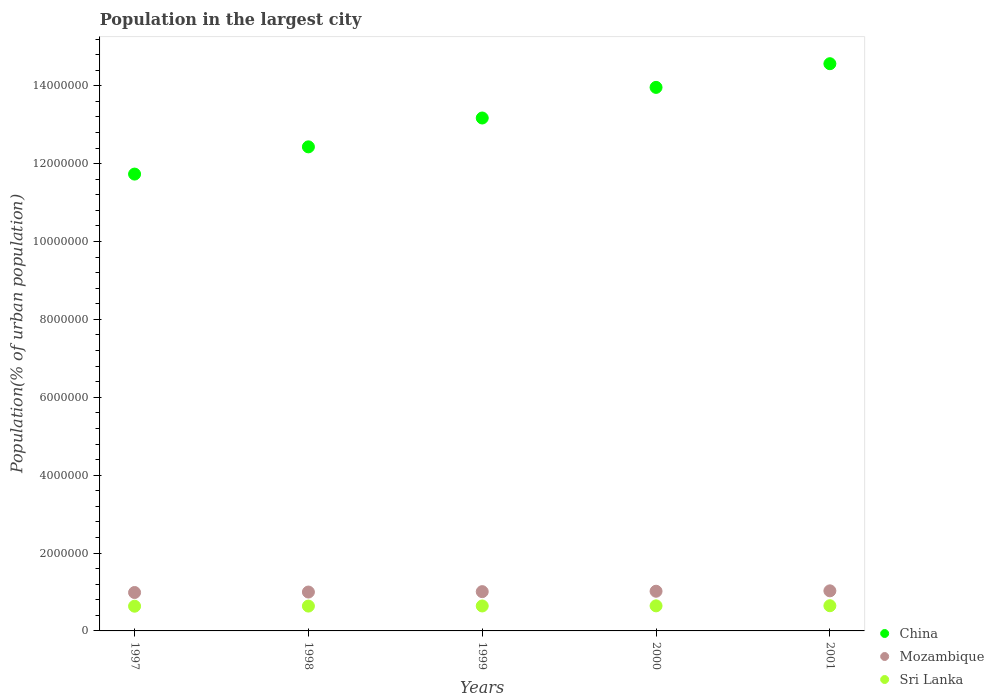Is the number of dotlines equal to the number of legend labels?
Ensure brevity in your answer.  Yes. What is the population in the largest city in Sri Lanka in 1999?
Your response must be concise. 6.41e+05. Across all years, what is the maximum population in the largest city in Sri Lanka?
Keep it short and to the point. 6.47e+05. Across all years, what is the minimum population in the largest city in Sri Lanka?
Make the answer very short. 6.35e+05. In which year was the population in the largest city in China minimum?
Offer a terse response. 1997. What is the total population in the largest city in Sri Lanka in the graph?
Your answer should be compact. 3.20e+06. What is the difference between the population in the largest city in Sri Lanka in 1999 and that in 2000?
Provide a short and direct response. -3049. What is the difference between the population in the largest city in Mozambique in 1999 and the population in the largest city in China in 2000?
Provide a succinct answer. -1.30e+07. What is the average population in the largest city in China per year?
Give a very brief answer. 1.32e+07. In the year 2001, what is the difference between the population in the largest city in Sri Lanka and population in the largest city in Mozambique?
Give a very brief answer. -3.82e+05. What is the ratio of the population in the largest city in Mozambique in 1999 to that in 2000?
Your answer should be compact. 0.99. Is the difference between the population in the largest city in Sri Lanka in 1997 and 1999 greater than the difference between the population in the largest city in Mozambique in 1997 and 1999?
Your response must be concise. Yes. What is the difference between the highest and the second highest population in the largest city in China?
Provide a short and direct response. 6.08e+05. What is the difference between the highest and the lowest population in the largest city in Mozambique?
Offer a terse response. 4.28e+04. Is the sum of the population in the largest city in Mozambique in 1997 and 1998 greater than the maximum population in the largest city in China across all years?
Offer a very short reply. No. How many years are there in the graph?
Your response must be concise. 5. What is the difference between two consecutive major ticks on the Y-axis?
Provide a short and direct response. 2.00e+06. Are the values on the major ticks of Y-axis written in scientific E-notation?
Your answer should be very brief. No. What is the title of the graph?
Your response must be concise. Population in the largest city. What is the label or title of the X-axis?
Make the answer very short. Years. What is the label or title of the Y-axis?
Your answer should be very brief. Population(% of urban population). What is the Population(% of urban population) of China in 1997?
Offer a very short reply. 1.17e+07. What is the Population(% of urban population) in Mozambique in 1997?
Your answer should be very brief. 9.87e+05. What is the Population(% of urban population) in Sri Lanka in 1997?
Make the answer very short. 6.35e+05. What is the Population(% of urban population) of China in 1998?
Keep it short and to the point. 1.24e+07. What is the Population(% of urban population) in Mozambique in 1998?
Offer a very short reply. 9.99e+05. What is the Population(% of urban population) in Sri Lanka in 1998?
Ensure brevity in your answer.  6.38e+05. What is the Population(% of urban population) of China in 1999?
Ensure brevity in your answer.  1.32e+07. What is the Population(% of urban population) in Mozambique in 1999?
Your response must be concise. 1.01e+06. What is the Population(% of urban population) of Sri Lanka in 1999?
Your answer should be very brief. 6.41e+05. What is the Population(% of urban population) of China in 2000?
Make the answer very short. 1.40e+07. What is the Population(% of urban population) in Mozambique in 2000?
Provide a succinct answer. 1.02e+06. What is the Population(% of urban population) in Sri Lanka in 2000?
Ensure brevity in your answer.  6.44e+05. What is the Population(% of urban population) in China in 2001?
Provide a succinct answer. 1.46e+07. What is the Population(% of urban population) in Mozambique in 2001?
Give a very brief answer. 1.03e+06. What is the Population(% of urban population) in Sri Lanka in 2001?
Your answer should be very brief. 6.47e+05. Across all years, what is the maximum Population(% of urban population) in China?
Provide a succinct answer. 1.46e+07. Across all years, what is the maximum Population(% of urban population) in Mozambique?
Your answer should be very brief. 1.03e+06. Across all years, what is the maximum Population(% of urban population) in Sri Lanka?
Your response must be concise. 6.47e+05. Across all years, what is the minimum Population(% of urban population) in China?
Ensure brevity in your answer.  1.17e+07. Across all years, what is the minimum Population(% of urban population) of Mozambique?
Your answer should be compact. 9.87e+05. Across all years, what is the minimum Population(% of urban population) in Sri Lanka?
Offer a terse response. 6.35e+05. What is the total Population(% of urban population) in China in the graph?
Your answer should be very brief. 6.59e+07. What is the total Population(% of urban population) in Mozambique in the graph?
Your answer should be very brief. 5.04e+06. What is the total Population(% of urban population) of Sri Lanka in the graph?
Give a very brief answer. 3.20e+06. What is the difference between the Population(% of urban population) in China in 1997 and that in 1998?
Provide a succinct answer. -6.99e+05. What is the difference between the Population(% of urban population) of Mozambique in 1997 and that in 1998?
Keep it short and to the point. -1.21e+04. What is the difference between the Population(% of urban population) in Sri Lanka in 1997 and that in 1998?
Keep it short and to the point. -3016. What is the difference between the Population(% of urban population) in China in 1997 and that in 1999?
Provide a succinct answer. -1.44e+06. What is the difference between the Population(% of urban population) in Mozambique in 1997 and that in 1999?
Keep it short and to the point. -2.22e+04. What is the difference between the Population(% of urban population) of Sri Lanka in 1997 and that in 1999?
Make the answer very short. -6046. What is the difference between the Population(% of urban population) of China in 1997 and that in 2000?
Your answer should be very brief. -2.23e+06. What is the difference between the Population(% of urban population) in Mozambique in 1997 and that in 2000?
Ensure brevity in your answer.  -3.25e+04. What is the difference between the Population(% of urban population) in Sri Lanka in 1997 and that in 2000?
Your answer should be very brief. -9095. What is the difference between the Population(% of urban population) in China in 1997 and that in 2001?
Your answer should be compact. -2.83e+06. What is the difference between the Population(% of urban population) of Mozambique in 1997 and that in 2001?
Provide a short and direct response. -4.28e+04. What is the difference between the Population(% of urban population) in Sri Lanka in 1997 and that in 2001?
Offer a very short reply. -1.22e+04. What is the difference between the Population(% of urban population) in China in 1998 and that in 1999?
Your answer should be compact. -7.41e+05. What is the difference between the Population(% of urban population) of Mozambique in 1998 and that in 1999?
Keep it short and to the point. -1.01e+04. What is the difference between the Population(% of urban population) in Sri Lanka in 1998 and that in 1999?
Offer a terse response. -3030. What is the difference between the Population(% of urban population) of China in 1998 and that in 2000?
Keep it short and to the point. -1.53e+06. What is the difference between the Population(% of urban population) of Mozambique in 1998 and that in 2000?
Keep it short and to the point. -2.04e+04. What is the difference between the Population(% of urban population) in Sri Lanka in 1998 and that in 2000?
Make the answer very short. -6079. What is the difference between the Population(% of urban population) of China in 1998 and that in 2001?
Your answer should be compact. -2.14e+06. What is the difference between the Population(% of urban population) of Mozambique in 1998 and that in 2001?
Your response must be concise. -3.07e+04. What is the difference between the Population(% of urban population) in Sri Lanka in 1998 and that in 2001?
Make the answer very short. -9134. What is the difference between the Population(% of urban population) in China in 1999 and that in 2000?
Your response must be concise. -7.86e+05. What is the difference between the Population(% of urban population) in Mozambique in 1999 and that in 2000?
Your answer should be compact. -1.03e+04. What is the difference between the Population(% of urban population) in Sri Lanka in 1999 and that in 2000?
Your response must be concise. -3049. What is the difference between the Population(% of urban population) in China in 1999 and that in 2001?
Keep it short and to the point. -1.39e+06. What is the difference between the Population(% of urban population) of Mozambique in 1999 and that in 2001?
Make the answer very short. -2.06e+04. What is the difference between the Population(% of urban population) in Sri Lanka in 1999 and that in 2001?
Ensure brevity in your answer.  -6104. What is the difference between the Population(% of urban population) in China in 2000 and that in 2001?
Your response must be concise. -6.08e+05. What is the difference between the Population(% of urban population) in Mozambique in 2000 and that in 2001?
Make the answer very short. -1.03e+04. What is the difference between the Population(% of urban population) of Sri Lanka in 2000 and that in 2001?
Provide a short and direct response. -3055. What is the difference between the Population(% of urban population) in China in 1997 and the Population(% of urban population) in Mozambique in 1998?
Offer a terse response. 1.07e+07. What is the difference between the Population(% of urban population) in China in 1997 and the Population(% of urban population) in Sri Lanka in 1998?
Provide a short and direct response. 1.11e+07. What is the difference between the Population(% of urban population) of Mozambique in 1997 and the Population(% of urban population) of Sri Lanka in 1998?
Provide a short and direct response. 3.49e+05. What is the difference between the Population(% of urban population) of China in 1997 and the Population(% of urban population) of Mozambique in 1999?
Offer a terse response. 1.07e+07. What is the difference between the Population(% of urban population) in China in 1997 and the Population(% of urban population) in Sri Lanka in 1999?
Make the answer very short. 1.11e+07. What is the difference between the Population(% of urban population) in Mozambique in 1997 and the Population(% of urban population) in Sri Lanka in 1999?
Your response must be concise. 3.46e+05. What is the difference between the Population(% of urban population) in China in 1997 and the Population(% of urban population) in Mozambique in 2000?
Your answer should be very brief. 1.07e+07. What is the difference between the Population(% of urban population) in China in 1997 and the Population(% of urban population) in Sri Lanka in 2000?
Ensure brevity in your answer.  1.11e+07. What is the difference between the Population(% of urban population) of Mozambique in 1997 and the Population(% of urban population) of Sri Lanka in 2000?
Make the answer very short. 3.43e+05. What is the difference between the Population(% of urban population) of China in 1997 and the Population(% of urban population) of Mozambique in 2001?
Offer a very short reply. 1.07e+07. What is the difference between the Population(% of urban population) of China in 1997 and the Population(% of urban population) of Sri Lanka in 2001?
Keep it short and to the point. 1.11e+07. What is the difference between the Population(% of urban population) in Mozambique in 1997 and the Population(% of urban population) in Sri Lanka in 2001?
Provide a succinct answer. 3.40e+05. What is the difference between the Population(% of urban population) in China in 1998 and the Population(% of urban population) in Mozambique in 1999?
Your answer should be compact. 1.14e+07. What is the difference between the Population(% of urban population) in China in 1998 and the Population(% of urban population) in Sri Lanka in 1999?
Provide a short and direct response. 1.18e+07. What is the difference between the Population(% of urban population) in Mozambique in 1998 and the Population(% of urban population) in Sri Lanka in 1999?
Make the answer very short. 3.58e+05. What is the difference between the Population(% of urban population) of China in 1998 and the Population(% of urban population) of Mozambique in 2000?
Your answer should be very brief. 1.14e+07. What is the difference between the Population(% of urban population) in China in 1998 and the Population(% of urban population) in Sri Lanka in 2000?
Your answer should be compact. 1.18e+07. What is the difference between the Population(% of urban population) of Mozambique in 1998 and the Population(% of urban population) of Sri Lanka in 2000?
Provide a succinct answer. 3.55e+05. What is the difference between the Population(% of urban population) in China in 1998 and the Population(% of urban population) in Mozambique in 2001?
Give a very brief answer. 1.14e+07. What is the difference between the Population(% of urban population) in China in 1998 and the Population(% of urban population) in Sri Lanka in 2001?
Provide a succinct answer. 1.18e+07. What is the difference between the Population(% of urban population) in Mozambique in 1998 and the Population(% of urban population) in Sri Lanka in 2001?
Your answer should be compact. 3.52e+05. What is the difference between the Population(% of urban population) of China in 1999 and the Population(% of urban population) of Mozambique in 2000?
Give a very brief answer. 1.22e+07. What is the difference between the Population(% of urban population) of China in 1999 and the Population(% of urban population) of Sri Lanka in 2000?
Provide a succinct answer. 1.25e+07. What is the difference between the Population(% of urban population) of Mozambique in 1999 and the Population(% of urban population) of Sri Lanka in 2000?
Your answer should be very brief. 3.65e+05. What is the difference between the Population(% of urban population) in China in 1999 and the Population(% of urban population) in Mozambique in 2001?
Provide a succinct answer. 1.21e+07. What is the difference between the Population(% of urban population) of China in 1999 and the Population(% of urban population) of Sri Lanka in 2001?
Your response must be concise. 1.25e+07. What is the difference between the Population(% of urban population) in Mozambique in 1999 and the Population(% of urban population) in Sri Lanka in 2001?
Provide a short and direct response. 3.62e+05. What is the difference between the Population(% of urban population) in China in 2000 and the Population(% of urban population) in Mozambique in 2001?
Provide a succinct answer. 1.29e+07. What is the difference between the Population(% of urban population) in China in 2000 and the Population(% of urban population) in Sri Lanka in 2001?
Provide a succinct answer. 1.33e+07. What is the difference between the Population(% of urban population) of Mozambique in 2000 and the Population(% of urban population) of Sri Lanka in 2001?
Make the answer very short. 3.72e+05. What is the average Population(% of urban population) in China per year?
Offer a very short reply. 1.32e+07. What is the average Population(% of urban population) in Mozambique per year?
Your answer should be very brief. 1.01e+06. What is the average Population(% of urban population) in Sri Lanka per year?
Provide a short and direct response. 6.41e+05. In the year 1997, what is the difference between the Population(% of urban population) of China and Population(% of urban population) of Mozambique?
Ensure brevity in your answer.  1.07e+07. In the year 1997, what is the difference between the Population(% of urban population) in China and Population(% of urban population) in Sri Lanka?
Provide a succinct answer. 1.11e+07. In the year 1997, what is the difference between the Population(% of urban population) in Mozambique and Population(% of urban population) in Sri Lanka?
Offer a very short reply. 3.52e+05. In the year 1998, what is the difference between the Population(% of urban population) in China and Population(% of urban population) in Mozambique?
Give a very brief answer. 1.14e+07. In the year 1998, what is the difference between the Population(% of urban population) of China and Population(% of urban population) of Sri Lanka?
Give a very brief answer. 1.18e+07. In the year 1998, what is the difference between the Population(% of urban population) in Mozambique and Population(% of urban population) in Sri Lanka?
Provide a succinct answer. 3.61e+05. In the year 1999, what is the difference between the Population(% of urban population) of China and Population(% of urban population) of Mozambique?
Your answer should be very brief. 1.22e+07. In the year 1999, what is the difference between the Population(% of urban population) in China and Population(% of urban population) in Sri Lanka?
Provide a short and direct response. 1.25e+07. In the year 1999, what is the difference between the Population(% of urban population) in Mozambique and Population(% of urban population) in Sri Lanka?
Keep it short and to the point. 3.68e+05. In the year 2000, what is the difference between the Population(% of urban population) of China and Population(% of urban population) of Mozambique?
Ensure brevity in your answer.  1.29e+07. In the year 2000, what is the difference between the Population(% of urban population) of China and Population(% of urban population) of Sri Lanka?
Keep it short and to the point. 1.33e+07. In the year 2000, what is the difference between the Population(% of urban population) in Mozambique and Population(% of urban population) in Sri Lanka?
Keep it short and to the point. 3.75e+05. In the year 2001, what is the difference between the Population(% of urban population) of China and Population(% of urban population) of Mozambique?
Ensure brevity in your answer.  1.35e+07. In the year 2001, what is the difference between the Population(% of urban population) of China and Population(% of urban population) of Sri Lanka?
Offer a terse response. 1.39e+07. In the year 2001, what is the difference between the Population(% of urban population) in Mozambique and Population(% of urban population) in Sri Lanka?
Keep it short and to the point. 3.82e+05. What is the ratio of the Population(% of urban population) in China in 1997 to that in 1998?
Offer a terse response. 0.94. What is the ratio of the Population(% of urban population) of Mozambique in 1997 to that in 1998?
Offer a very short reply. 0.99. What is the ratio of the Population(% of urban population) of Sri Lanka in 1997 to that in 1998?
Your response must be concise. 1. What is the ratio of the Population(% of urban population) of China in 1997 to that in 1999?
Offer a terse response. 0.89. What is the ratio of the Population(% of urban population) of Mozambique in 1997 to that in 1999?
Give a very brief answer. 0.98. What is the ratio of the Population(% of urban population) of Sri Lanka in 1997 to that in 1999?
Offer a terse response. 0.99. What is the ratio of the Population(% of urban population) in China in 1997 to that in 2000?
Provide a short and direct response. 0.84. What is the ratio of the Population(% of urban population) in Mozambique in 1997 to that in 2000?
Offer a terse response. 0.97. What is the ratio of the Population(% of urban population) of Sri Lanka in 1997 to that in 2000?
Ensure brevity in your answer.  0.99. What is the ratio of the Population(% of urban population) of China in 1997 to that in 2001?
Give a very brief answer. 0.81. What is the ratio of the Population(% of urban population) in Mozambique in 1997 to that in 2001?
Offer a very short reply. 0.96. What is the ratio of the Population(% of urban population) of Sri Lanka in 1997 to that in 2001?
Ensure brevity in your answer.  0.98. What is the ratio of the Population(% of urban population) of China in 1998 to that in 1999?
Offer a terse response. 0.94. What is the ratio of the Population(% of urban population) in China in 1998 to that in 2000?
Give a very brief answer. 0.89. What is the ratio of the Population(% of urban population) of Sri Lanka in 1998 to that in 2000?
Your answer should be compact. 0.99. What is the ratio of the Population(% of urban population) of China in 1998 to that in 2001?
Your response must be concise. 0.85. What is the ratio of the Population(% of urban population) of Mozambique in 1998 to that in 2001?
Ensure brevity in your answer.  0.97. What is the ratio of the Population(% of urban population) of Sri Lanka in 1998 to that in 2001?
Give a very brief answer. 0.99. What is the ratio of the Population(% of urban population) of China in 1999 to that in 2000?
Make the answer very short. 0.94. What is the ratio of the Population(% of urban population) in China in 1999 to that in 2001?
Provide a short and direct response. 0.9. What is the ratio of the Population(% of urban population) in Sri Lanka in 1999 to that in 2001?
Offer a terse response. 0.99. What is the ratio of the Population(% of urban population) in China in 2000 to that in 2001?
Provide a succinct answer. 0.96. What is the ratio of the Population(% of urban population) of Mozambique in 2000 to that in 2001?
Offer a very short reply. 0.99. What is the difference between the highest and the second highest Population(% of urban population) of China?
Keep it short and to the point. 6.08e+05. What is the difference between the highest and the second highest Population(% of urban population) of Mozambique?
Give a very brief answer. 1.03e+04. What is the difference between the highest and the second highest Population(% of urban population) of Sri Lanka?
Give a very brief answer. 3055. What is the difference between the highest and the lowest Population(% of urban population) in China?
Provide a short and direct response. 2.83e+06. What is the difference between the highest and the lowest Population(% of urban population) in Mozambique?
Provide a succinct answer. 4.28e+04. What is the difference between the highest and the lowest Population(% of urban population) of Sri Lanka?
Make the answer very short. 1.22e+04. 